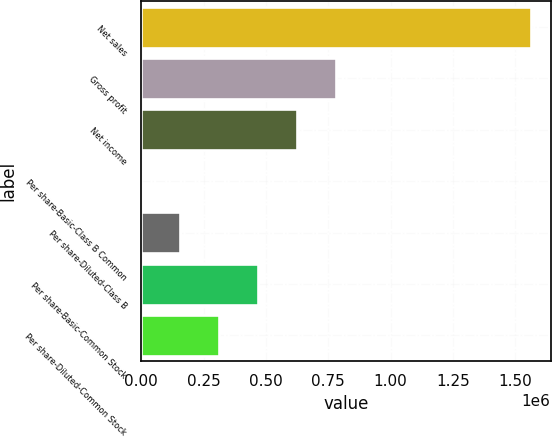Convert chart to OTSL. <chart><loc_0><loc_0><loc_500><loc_500><bar_chart><fcel>Net sales<fcel>Gross profit<fcel>Net income<fcel>Per share-Basic-Class B Common<fcel>Per share-Diluted-Class B<fcel>Per share-Basic-Common Stock<fcel>Per share-Diluted-Common Stock<nl><fcel>1.56422e+06<fcel>782112<fcel>625690<fcel>0.65<fcel>156423<fcel>469267<fcel>312845<nl></chart> 